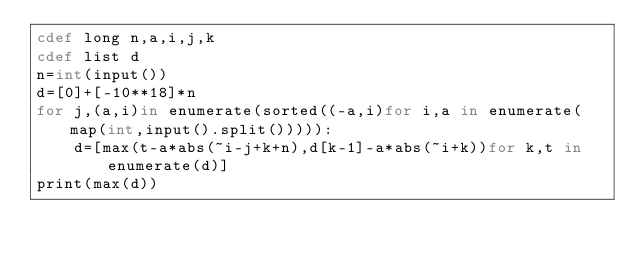<code> <loc_0><loc_0><loc_500><loc_500><_Cython_>cdef long n,a,i,j,k
cdef list d
n=int(input())
d=[0]+[-10**18]*n
for j,(a,i)in enumerate(sorted((-a,i)for i,a in enumerate(map(int,input().split())))):
    d=[max(t-a*abs(~i-j+k+n),d[k-1]-a*abs(~i+k))for k,t in enumerate(d)]
print(max(d))</code> 